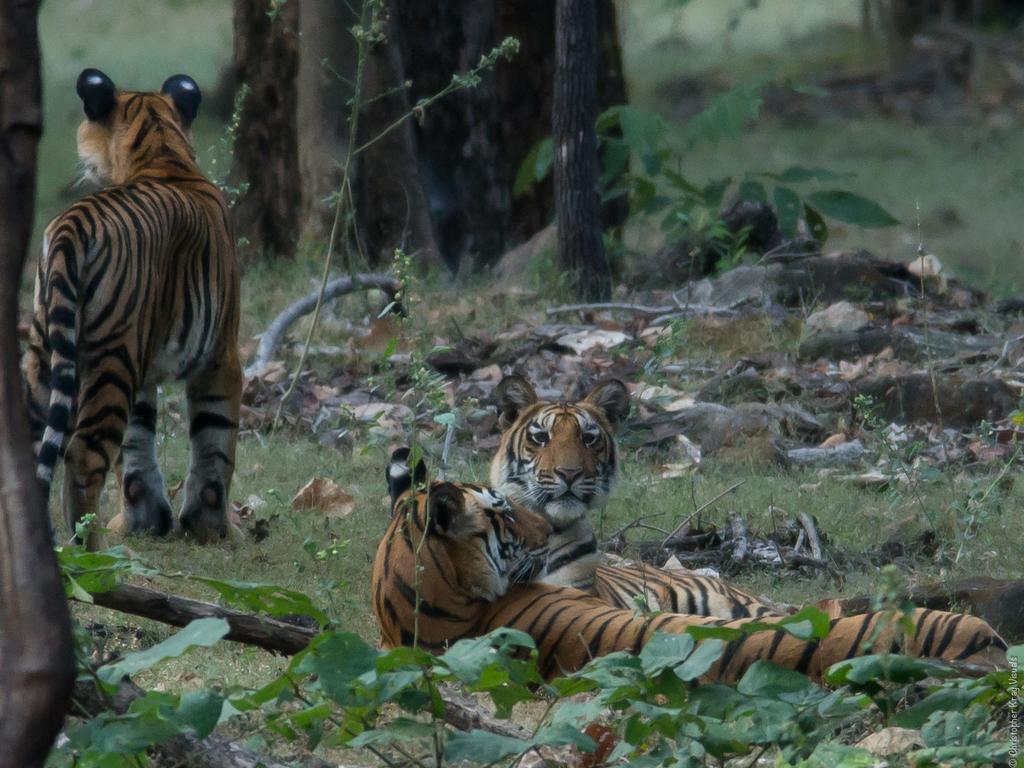How would you summarize this image in a sentence or two? In this image we can see tigers on the grass. In the background we can see trees and plants. 